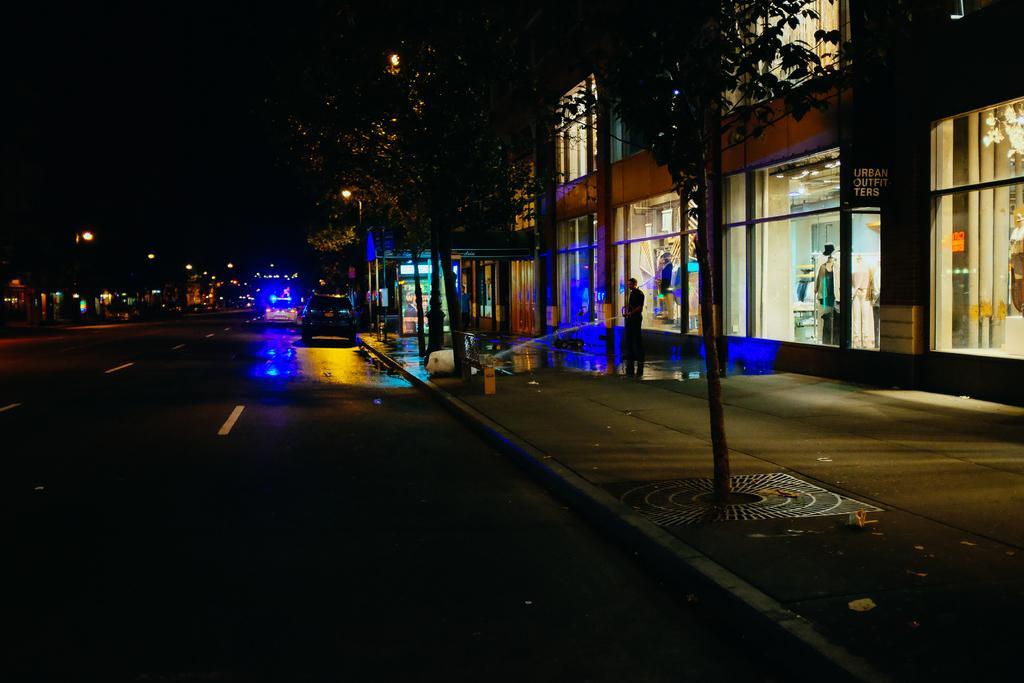How would you summarize this image in a sentence or two? In this picture we can see vehicles on the road, two people on the footpath, trees, lights, mannequins, name board, buildings with windows and some objects and in the background it is dark. 